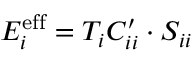Convert formula to latex. <formula><loc_0><loc_0><loc_500><loc_500>E _ { i } ^ { e f f } = T _ { i } C _ { i i } ^ { \prime } \cdot S _ { i i }</formula> 